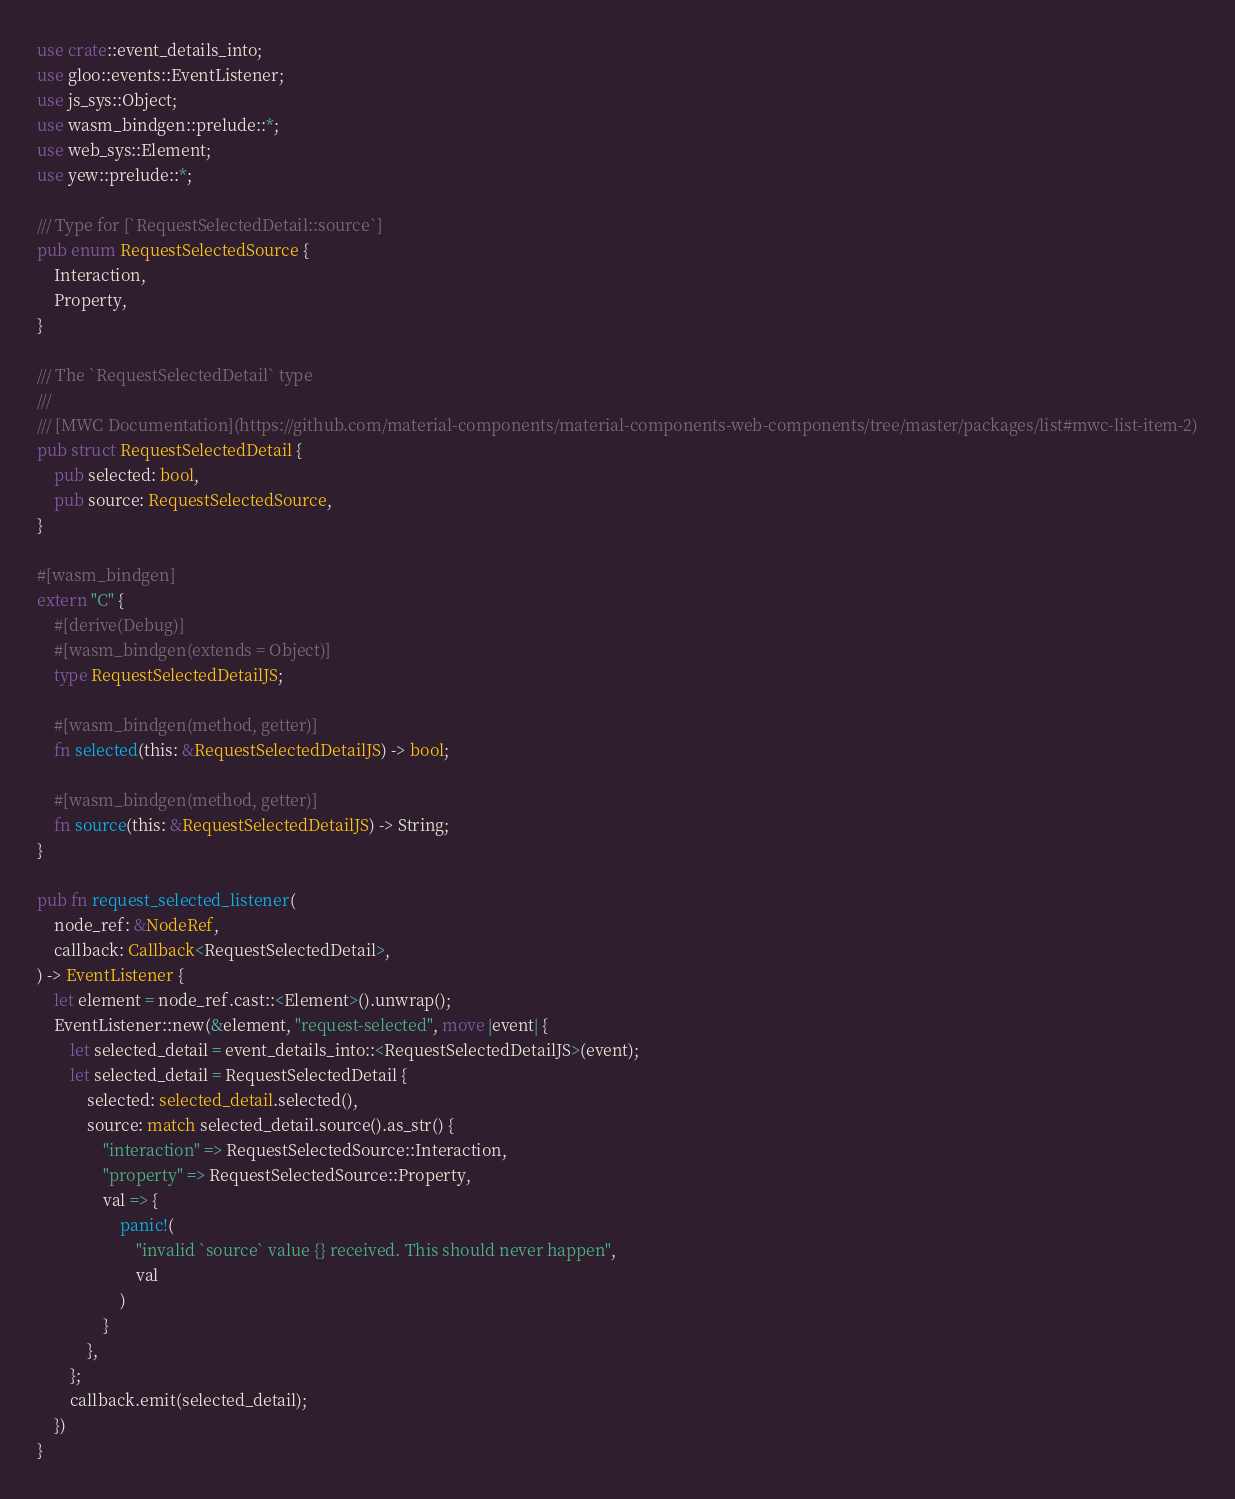<code> <loc_0><loc_0><loc_500><loc_500><_Rust_>use crate::event_details_into;
use gloo::events::EventListener;
use js_sys::Object;
use wasm_bindgen::prelude::*;
use web_sys::Element;
use yew::prelude::*;

/// Type for [`RequestSelectedDetail::source`]
pub enum RequestSelectedSource {
    Interaction,
    Property,
}

/// The `RequestSelectedDetail` type
///
/// [MWC Documentation](https://github.com/material-components/material-components-web-components/tree/master/packages/list#mwc-list-item-2)
pub struct RequestSelectedDetail {
    pub selected: bool,
    pub source: RequestSelectedSource,
}

#[wasm_bindgen]
extern "C" {
    #[derive(Debug)]
    #[wasm_bindgen(extends = Object)]
    type RequestSelectedDetailJS;

    #[wasm_bindgen(method, getter)]
    fn selected(this: &RequestSelectedDetailJS) -> bool;

    #[wasm_bindgen(method, getter)]
    fn source(this: &RequestSelectedDetailJS) -> String;
}

pub fn request_selected_listener(
    node_ref: &NodeRef,
    callback: Callback<RequestSelectedDetail>,
) -> EventListener {
    let element = node_ref.cast::<Element>().unwrap();
    EventListener::new(&element, "request-selected", move |event| {
        let selected_detail = event_details_into::<RequestSelectedDetailJS>(event);
        let selected_detail = RequestSelectedDetail {
            selected: selected_detail.selected(),
            source: match selected_detail.source().as_str() {
                "interaction" => RequestSelectedSource::Interaction,
                "property" => RequestSelectedSource::Property,
                val => {
                    panic!(
                        "invalid `source` value {} received. This should never happen",
                        val
                    )
                }
            },
        };
        callback.emit(selected_detail);
    })
}
</code> 